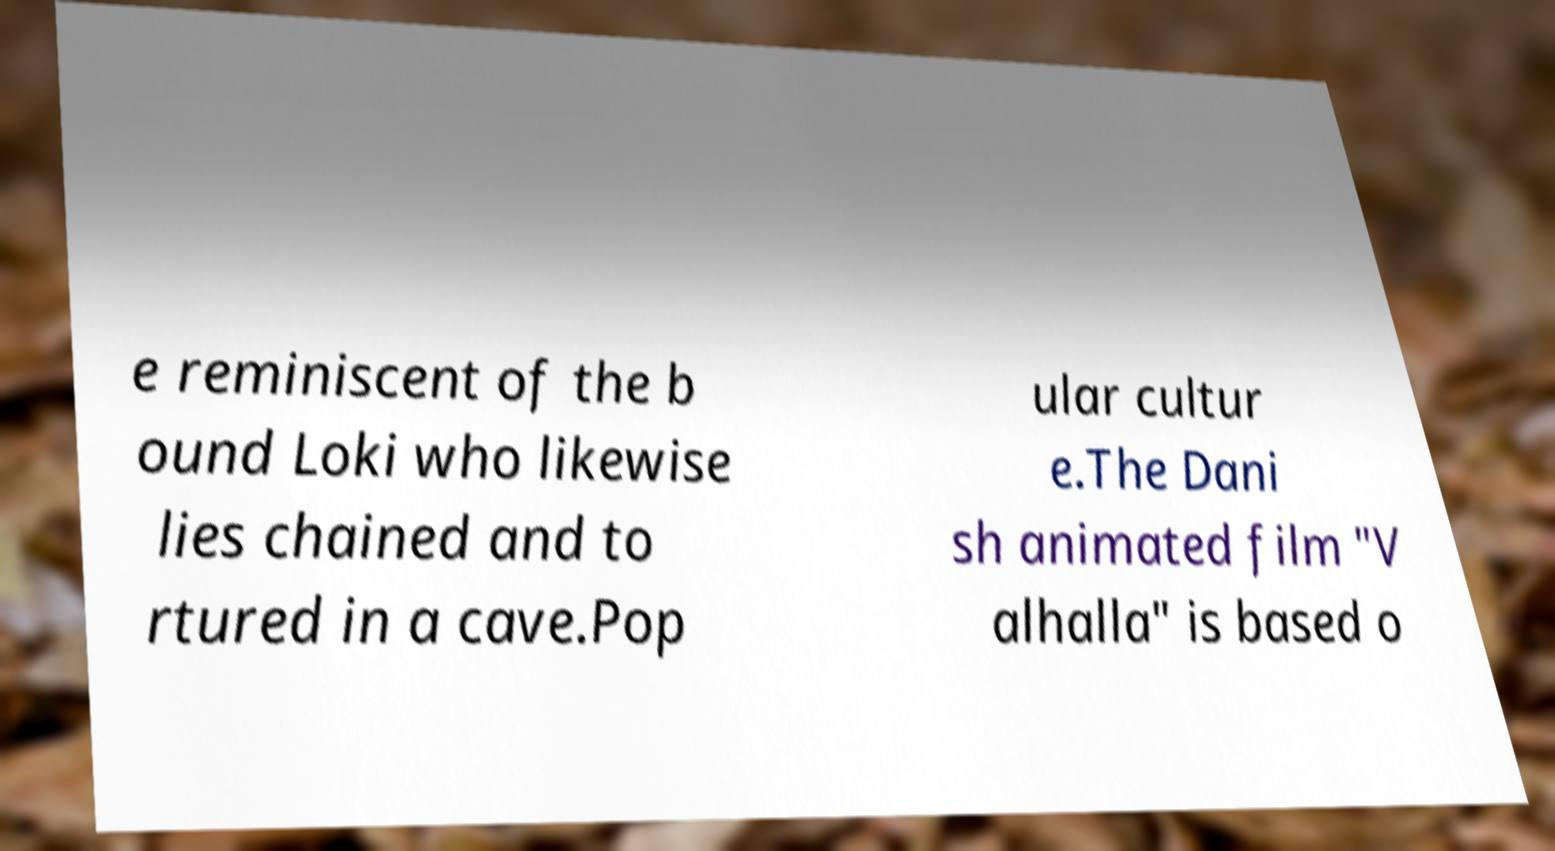Can you read and provide the text displayed in the image?This photo seems to have some interesting text. Can you extract and type it out for me? e reminiscent of the b ound Loki who likewise lies chained and to rtured in a cave.Pop ular cultur e.The Dani sh animated film "V alhalla" is based o 